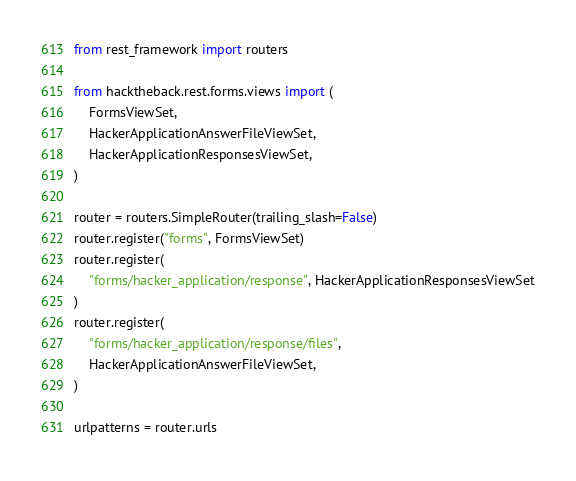<code> <loc_0><loc_0><loc_500><loc_500><_Python_>from rest_framework import routers

from hacktheback.rest.forms.views import (
    FormsViewSet,
    HackerApplicationAnswerFileViewSet,
    HackerApplicationResponsesViewSet,
)

router = routers.SimpleRouter(trailing_slash=False)
router.register("forms", FormsViewSet)
router.register(
    "forms/hacker_application/response", HackerApplicationResponsesViewSet
)
router.register(
    "forms/hacker_application/response/files",
    HackerApplicationAnswerFileViewSet,
)

urlpatterns = router.urls
</code> 